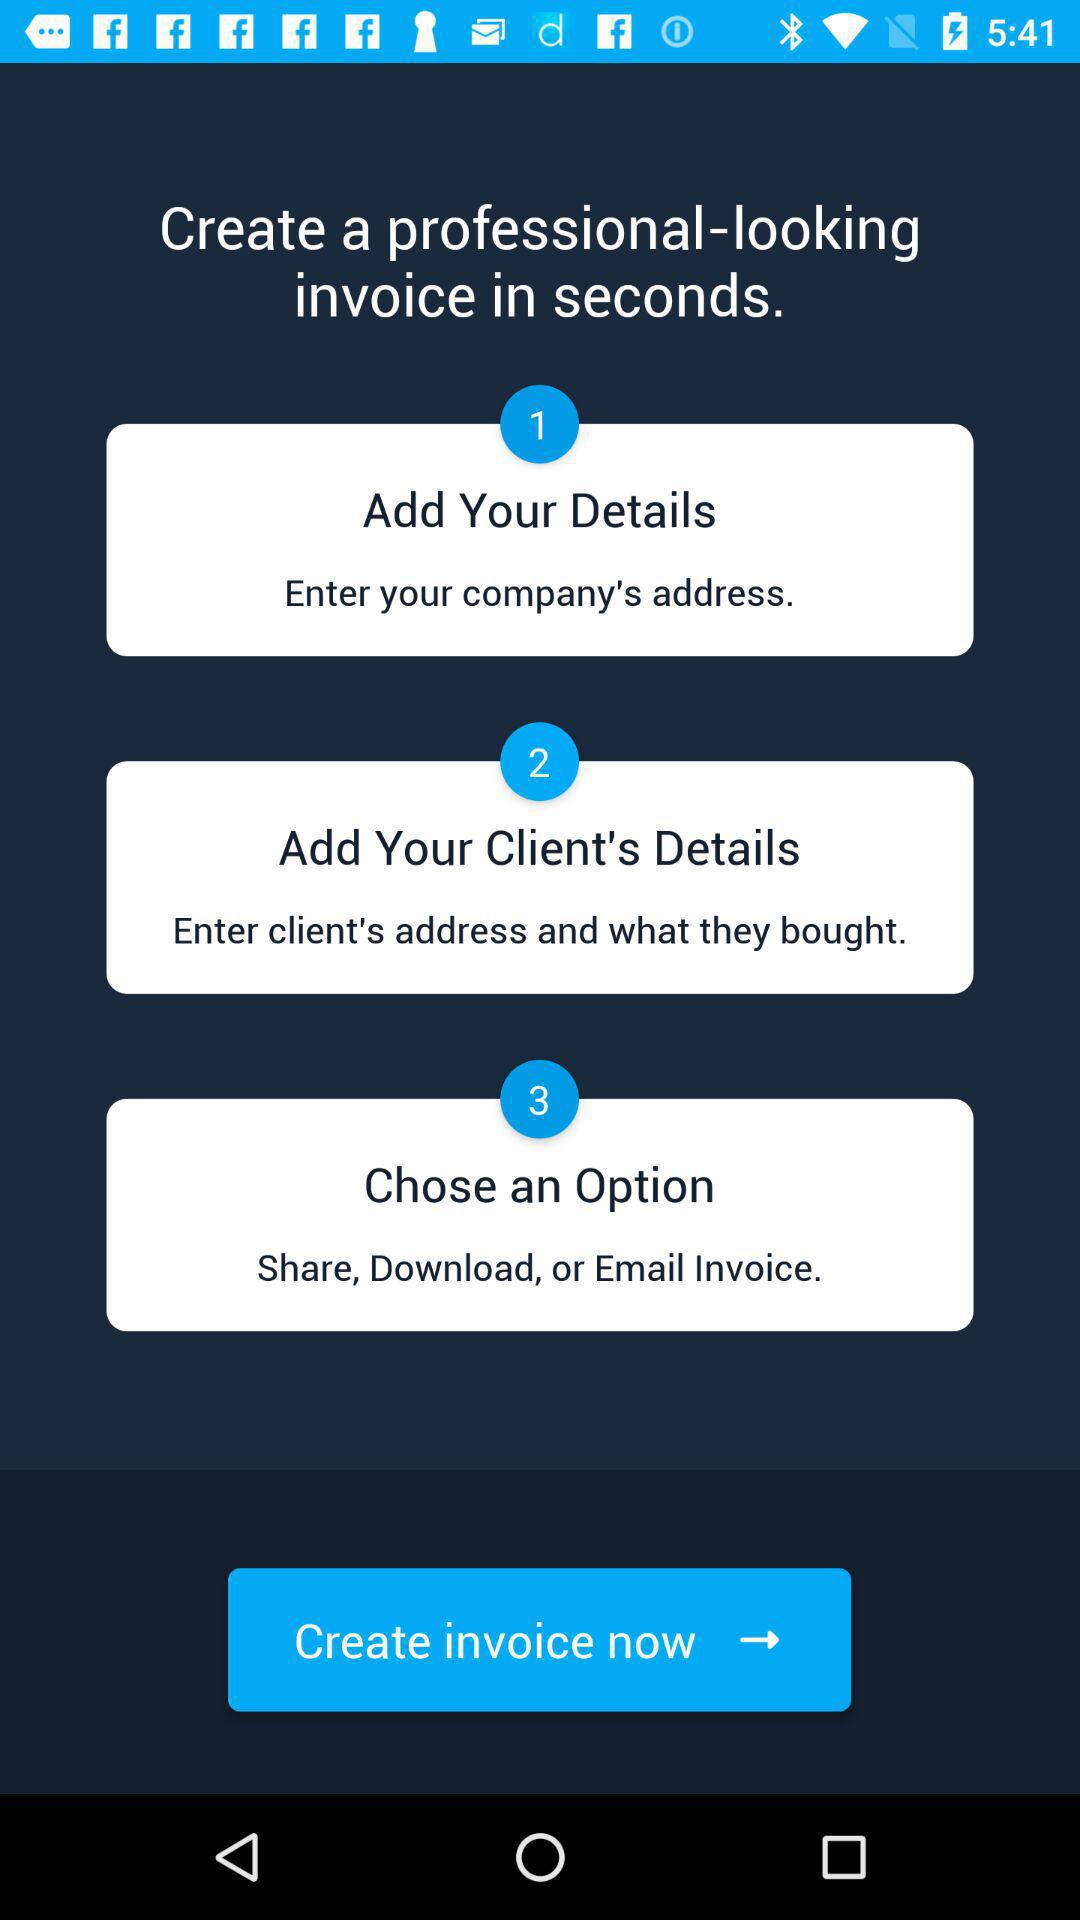How many steps are there in the invoice creation process?
Answer the question using a single word or phrase. 3 